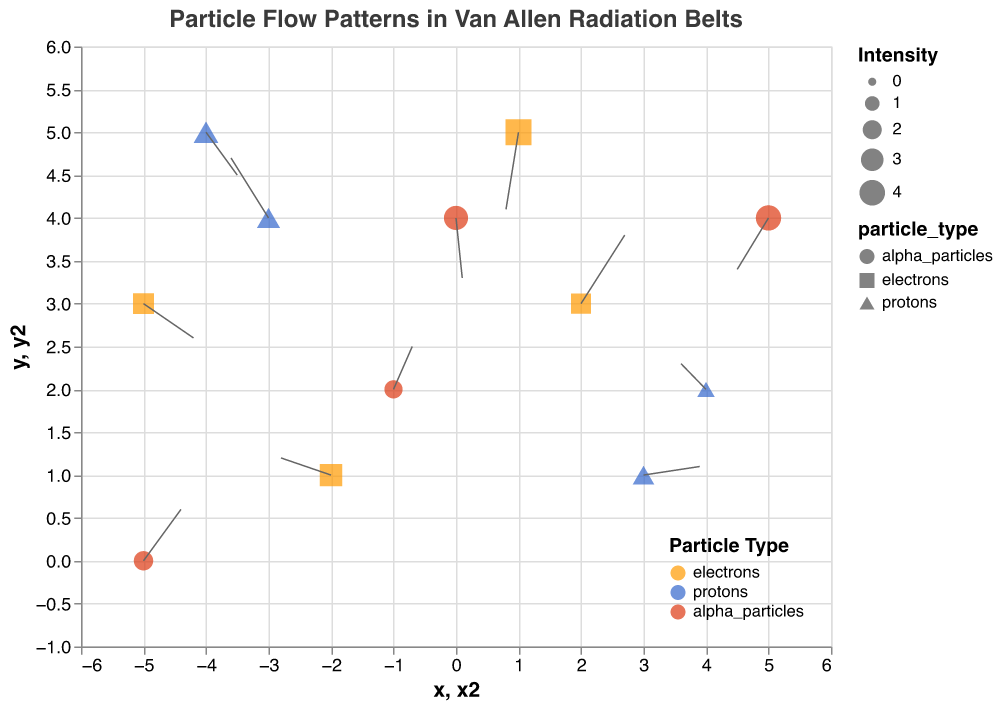What is the title of the figure? The title is often placed at the top of the figure. The title text directly states the subject of the visualization.
Answer: Particle Flow Patterns in Van Allen Radiation Belts Which particle type has the highest intensity value in the plot? Intensity is indicated by the size of the points. The largest point corresponds to the highest intensity, which also matches with the particle type color.
Answer: electrons How many protons are represented in the plot? By examining the plot and counting the points colored blue (representing protons), we get the total number of data points for protons.
Answer: 4 What are the average intensity values for electrons and protons? Sum the intensity values for each particle type and divide by their count. For electrons, the intensities are 2.5, 4.1, 2.3, and 2.9 (sum is 11.8 and average is 11.8/4 = 2.95). For protons, the intensities are 3.2, 2.7, 1.6, and 3.7 (sum is 11.2 and average is 11.2/4 = 2.8).
Answer: Electrons: 2.95, Protons: 2.8 Which data point has the largest direction vector (u, v)? Compute the magnitude of direction vectors (sqrt(u^2 + v^2)) for each point. The vector with the largest magnitude belongs to the data point (-5, 3) with u = 0.8 and v = -0.4 (magnitude is sqrt(0.8^2 + (-0.4)^2) = 0.894).
Answer: (-5, 3) What is the net change in the x-direction for protons? Find the sum of the 'u' components for all protons. These components are -0.6, 0.9, -0.4, and 0.5. The total change in x-direction is -0.6 + 0.9 - 0.4 + 0.5 = 0.4.
Answer: 0.4 Which particle type shows the most consistent flow pattern in one direction? Consistent flow pattern means similar direction vectors for a particle type. By examining each particle type's vectors, electrons generally show more consistency in a given direction, with vector components close to each other.
Answer: electrons Are there any data points where the particle moves straight horizontally or vertically? Look for vectors with 0 in either the u or v component. The point (3, 1) with u = 0.9 and v = 0.1 is close to purely horizontal. Likewise, point (4, 2) with u = -0.4 and v = 0.3 is close to horizontal. No vector is purely vertical.
Answer: Yes, (3, 1) and (4, 2) are close to horizontal 